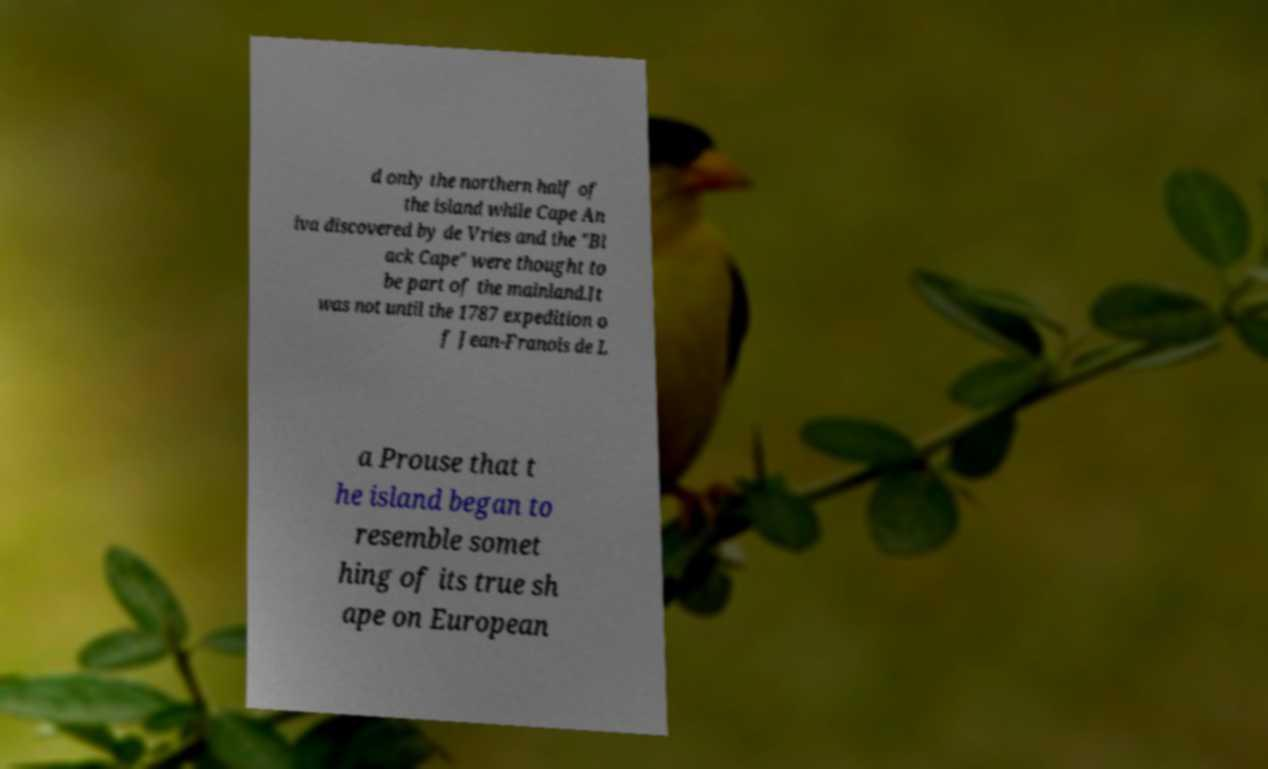Please read and relay the text visible in this image. What does it say? d only the northern half of the island while Cape An iva discovered by de Vries and the "Bl ack Cape" were thought to be part of the mainland.It was not until the 1787 expedition o f Jean-Franois de L a Prouse that t he island began to resemble somet hing of its true sh ape on European 